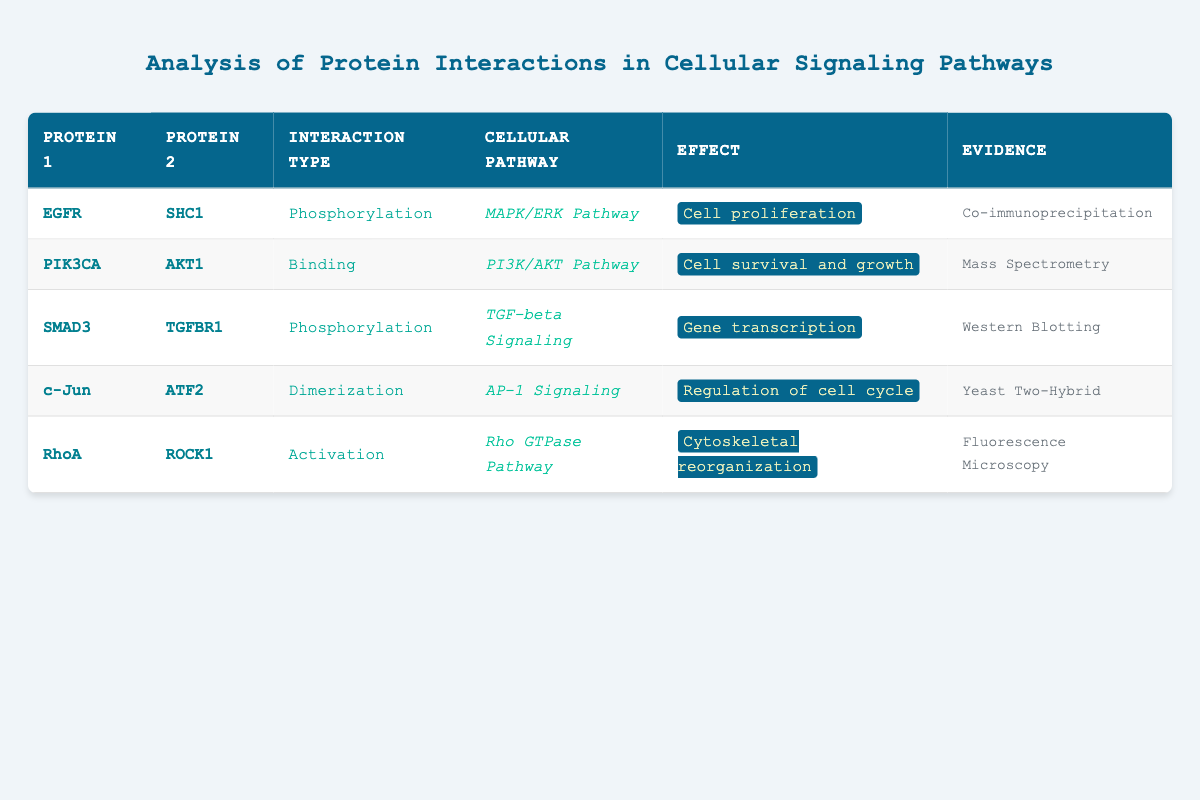What are the proteins involved in the MAPK/ERK Pathway? To find the proteins related to the MAPK/ERK Pathway, I look at the "Cellular Pathway" column and search for "MAPK/ERK Pathway." The corresponding row shows "EGFR" and "SHC1" as the proteins.
Answer: EGFR, SHC1 Which interaction type is associated with PIK3CA and AKT1? In the row corresponding to PIK3CA and AKT1, I check the "Interaction Type" column, which shows "Binding." Thus, this is the interaction type associated with these proteins.
Answer: Binding Is there any phosphorylation interaction detected in the table? I look through the "Interaction Type" column for the term "Phosphorylation." I find two instances: one involving "EGFR" and "SHC1" and another with "SMAD3" and "TGFBR1." Therefore, the answer to this question is yes.
Answer: Yes How many unique interaction types are listed in total? By counting the different entries in the "Interaction Type" column, I see five unique types: Phosphorylation, Binding, Dimerization, Activation. To ensure I don’t miss any, I confirm there are no duplicates.
Answer: 5 What effect is associated with the interaction between RhoA and ROCK1? I refer to the row with RhoA and ROCK1, and check the "Effect" column, which reveals that the effect is "Cytoskeletal reorganization." Thus, that is the direct answer to the question.
Answer: Cytoskeletal reorganization Which protein interacts with TGFBR1 and what is the type of interaction? Looking for the row with TGFBR1, I find "SMAD3" as the interacting protein in the "Protein 1" column. The "Interaction Type" column indicates that the type of interaction is "Phosphorylation." Therefore, both details are identified.
Answer: SMAD3, Phosphorylation What is the common effect shared by proteins in both the Rho GTPase Pathway and the PI3K/AKT Pathway? I check the "Effect" column entries for both pathways: for RhoA and ROCK1 in the Rho GTPase Pathway, the effect is "Cytoskeletal reorganization," and for PIK3CA and AKT1 in the PI3K/AKT Pathway, the effect is "Cell survival and growth." There is no common effect shared.
Answer: None How many protein interactions lead to gene transcription according to the table? I review the "Effect" column for instances of "Gene transcription." The only row with this effect corresponds to "SMAD3" and "TGFBR1." Therefore, there is only one interaction that leads to gene transcription.
Answer: 1 